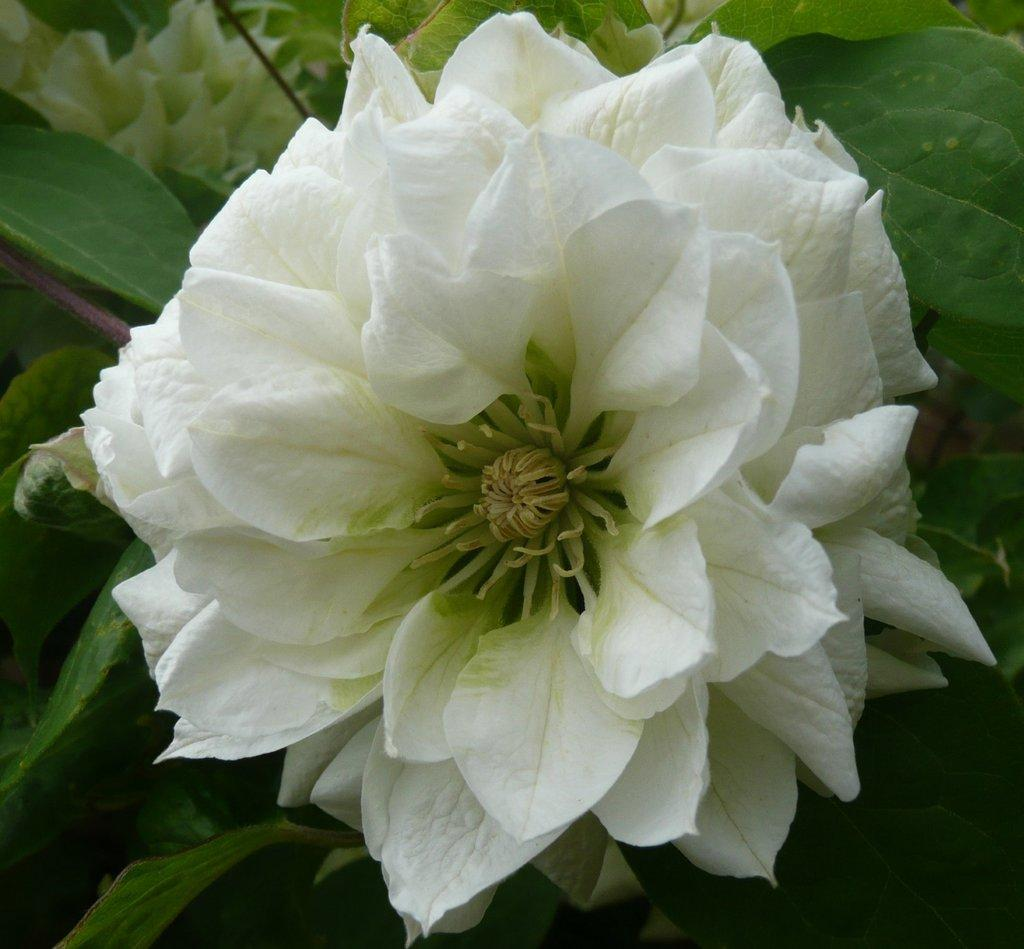What type of flower is in the image? There is a white flower in the image. What else can be seen in the background of the image? There are leaves visible in the background of the image. Is there a fire burning near the white flower in the image? No, there is no fire present in the image. 